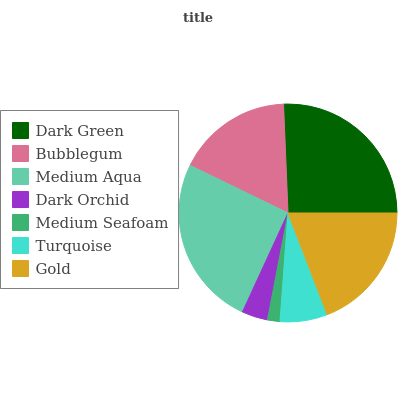Is Medium Seafoam the minimum?
Answer yes or no. Yes. Is Dark Green the maximum?
Answer yes or no. Yes. Is Bubblegum the minimum?
Answer yes or no. No. Is Bubblegum the maximum?
Answer yes or no. No. Is Dark Green greater than Bubblegum?
Answer yes or no. Yes. Is Bubblegum less than Dark Green?
Answer yes or no. Yes. Is Bubblegum greater than Dark Green?
Answer yes or no. No. Is Dark Green less than Bubblegum?
Answer yes or no. No. Is Bubblegum the high median?
Answer yes or no. Yes. Is Bubblegum the low median?
Answer yes or no. Yes. Is Gold the high median?
Answer yes or no. No. Is Gold the low median?
Answer yes or no. No. 